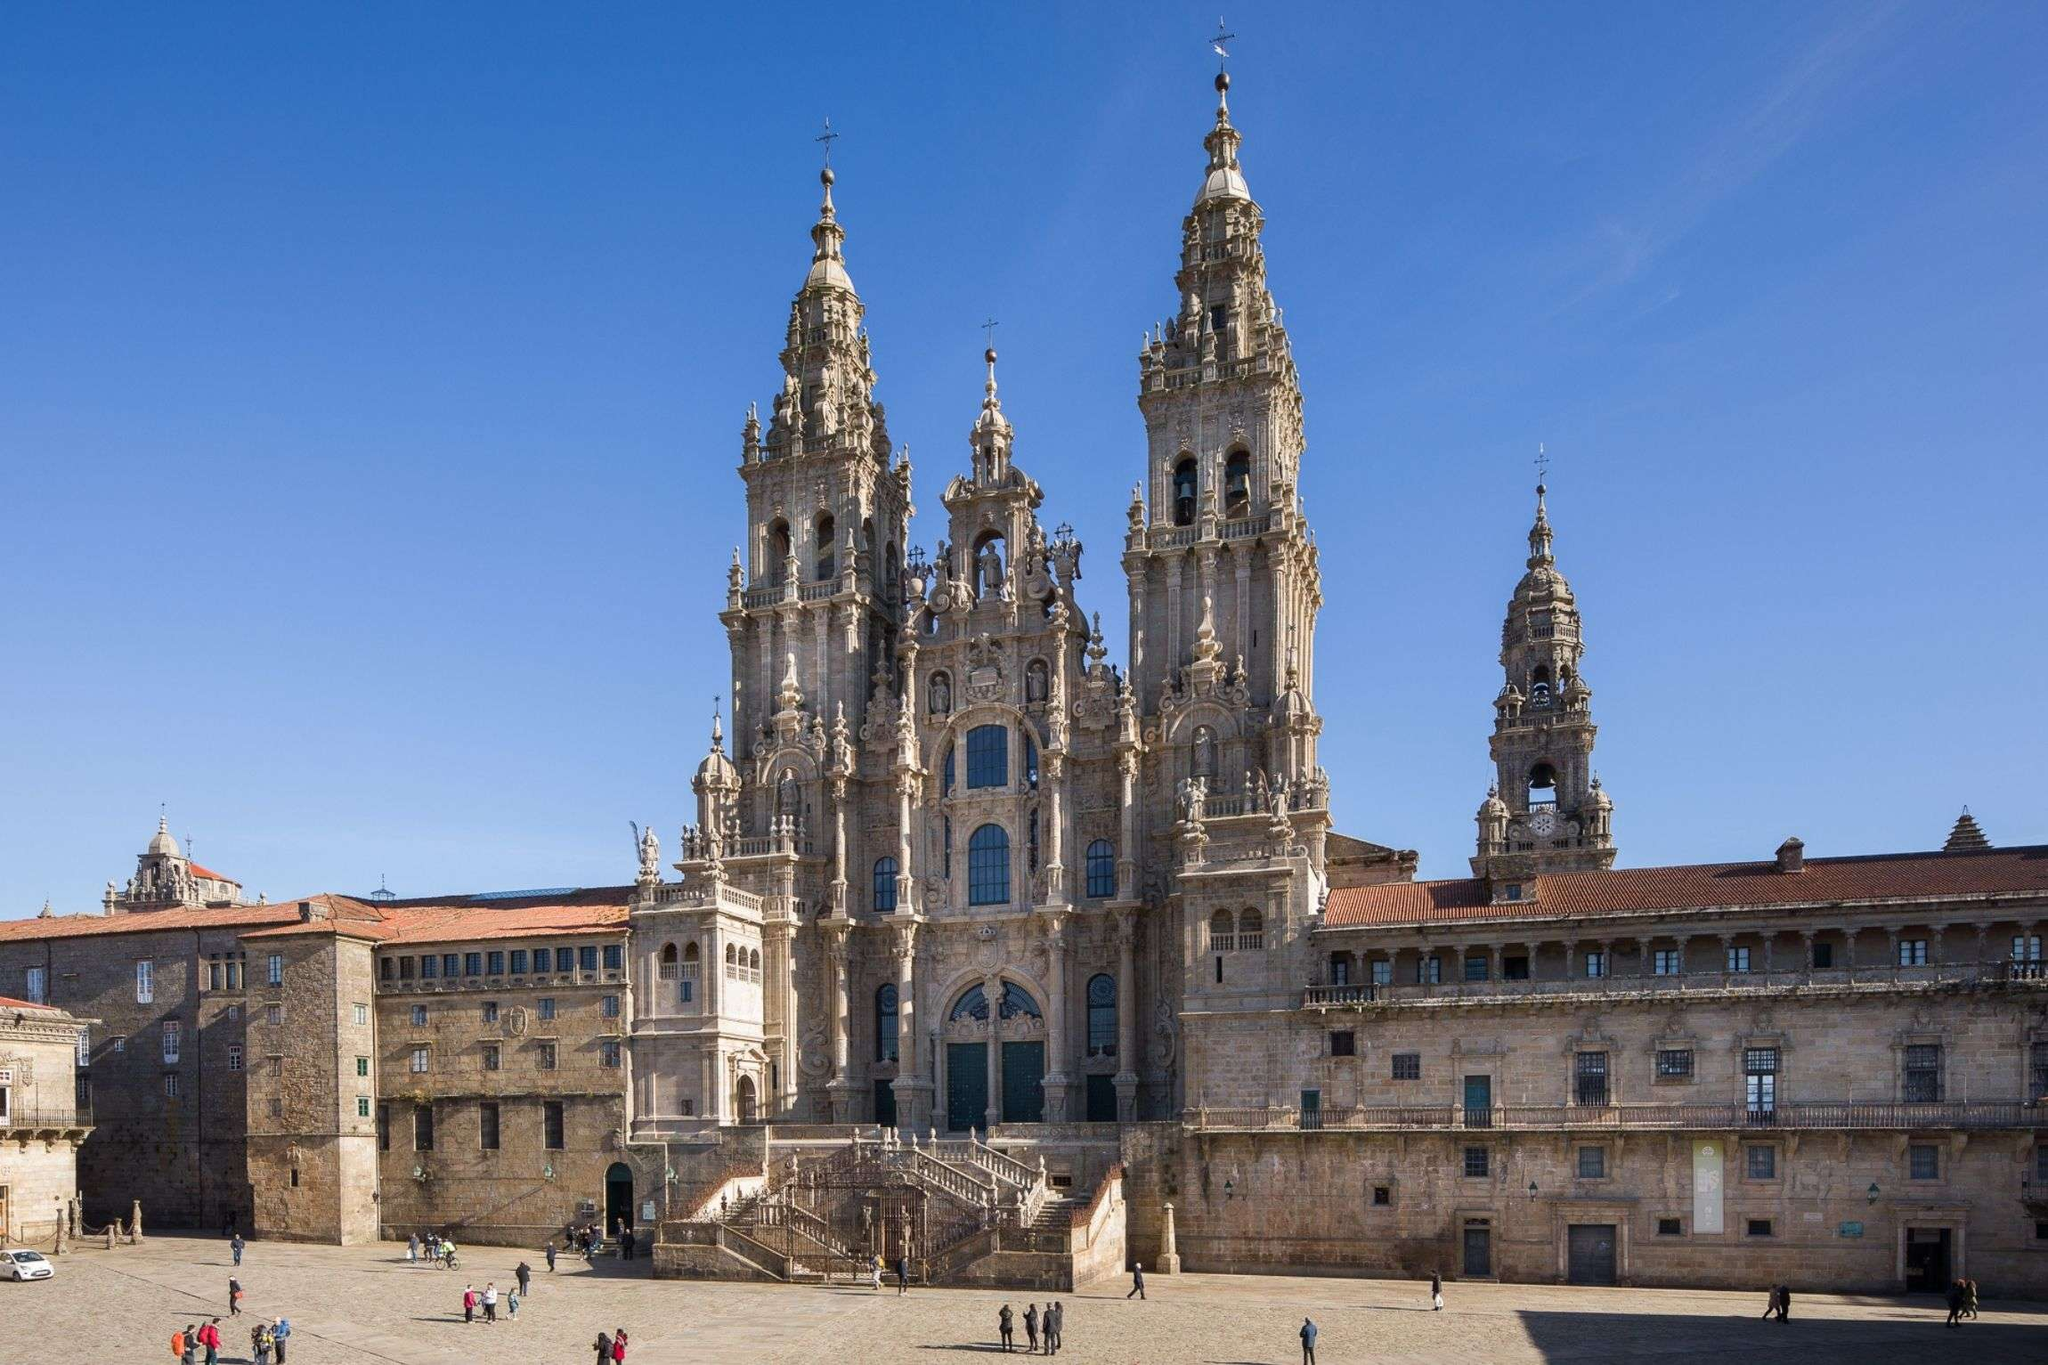Write a detailed description of the given image. The image showcases the stunning Cathedral Santiago De Compostela in Spain, a significant landmark on the historically revered Camino de Santiago pilgrimage route. This architectural marvel is built primarily in the Baroque and Gothic styles, evident from its elaborate stone carvings and ornate spires that rise majestically against a pristine blue sky. The façade, richly adorned with statues of religious figures, evokes a sense of historical depth and spiritual gravitas. The cathedral's large, solid doors and the meticulously crafted windows reflect its centuries-old heritage and artistic dedication. Surrounding the cathedral is a spacious plaza, where people are seen gathering, reflecting its ongoing role as a center for both tourism and pilgrimage. 